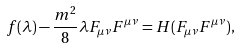Convert formula to latex. <formula><loc_0><loc_0><loc_500><loc_500>f ( \lambda ) - \frac { m ^ { 2 } } { 8 } \lambda F _ { \mu \nu } F ^ { \mu \nu } = H ( F _ { \mu \nu } F ^ { \mu \nu } ) ,</formula> 